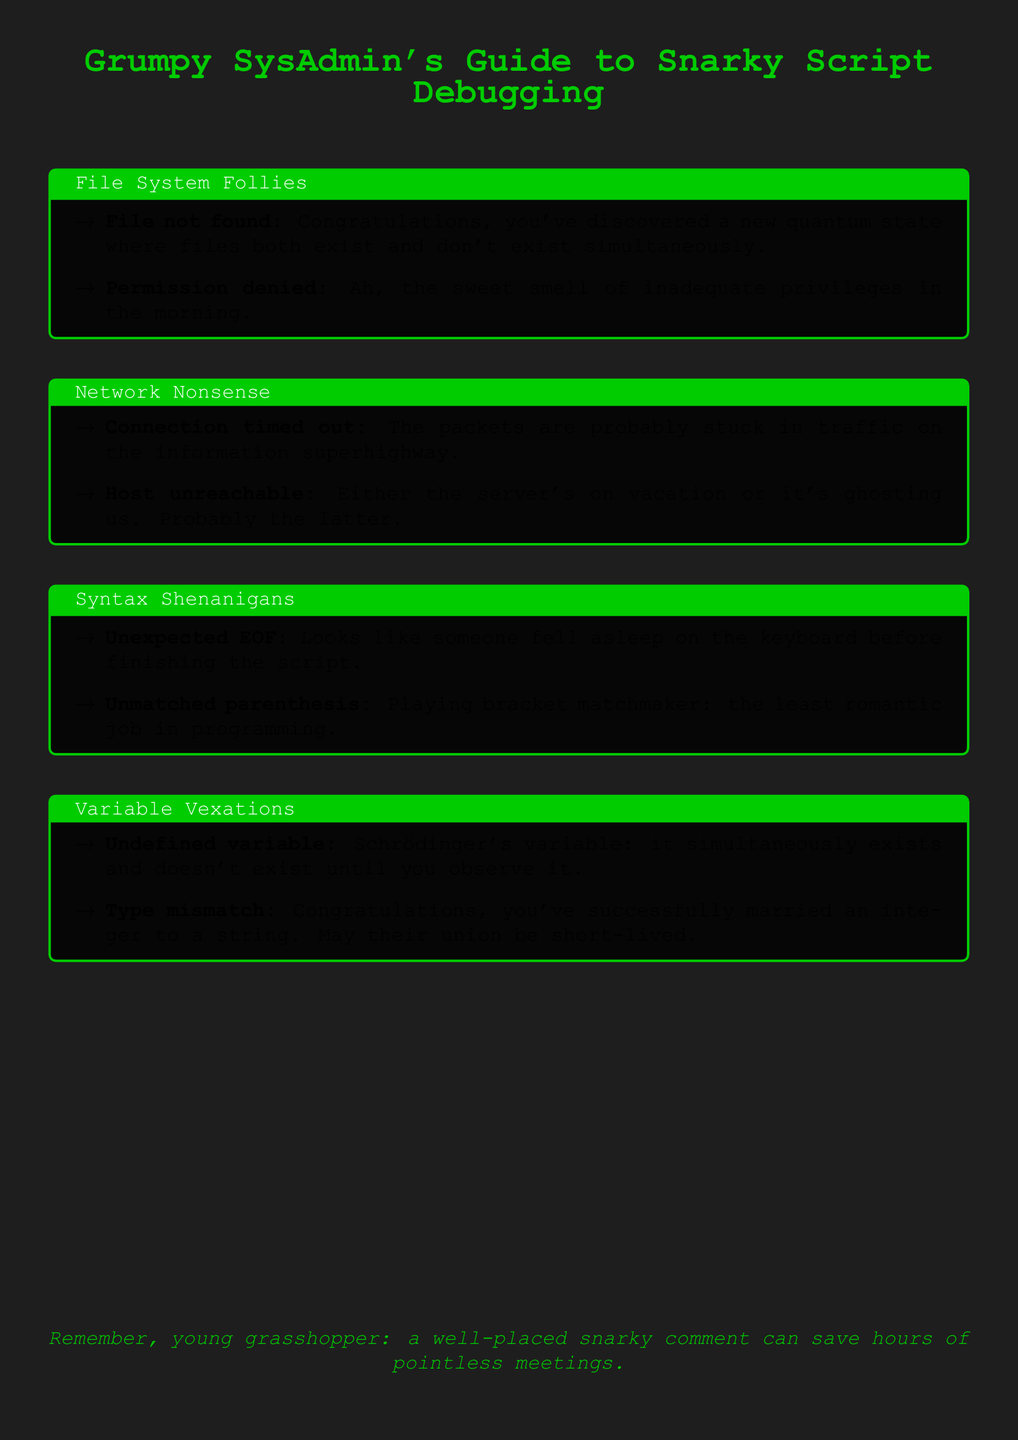What is the title of the document? The title is indicated at the start of the document and is "Grumpy SysAdmin's Guide to Snarky Script Debugging."
Answer: Grumpy SysAdmin's Guide to Snarky Script Debugging How many sections are in the document? The document contains four sections: File System Follies, Network Nonsense, Syntax Shenanigans, and Variable Vexations.
Answer: Four What is the error message for a file not found? This information is found in the File System Follies section, where it states, "Congratulations, you've discovered a new quantum state where files both exist and don't exist simultaneously."
Answer: Congratulations, you've discovered a new quantum state where files both exist and don't exist simultaneously What humorous comment is associated with a connection timed out error? This comment is located in the Network Nonsense section where it states, "The packets are probably stuck in traffic on the information superhighway."
Answer: The packets are probably stuck in traffic on the information superhighway What is the humorous interpretation of an undefined variable? This can be found in the Variable Vexations section, where it states, "Schrödinger's variable: it simultaneously exists and doesn't exist until you observe it."
Answer: Schrödinger's variable: it simultaneously exists and doesn't exist until you observe it 